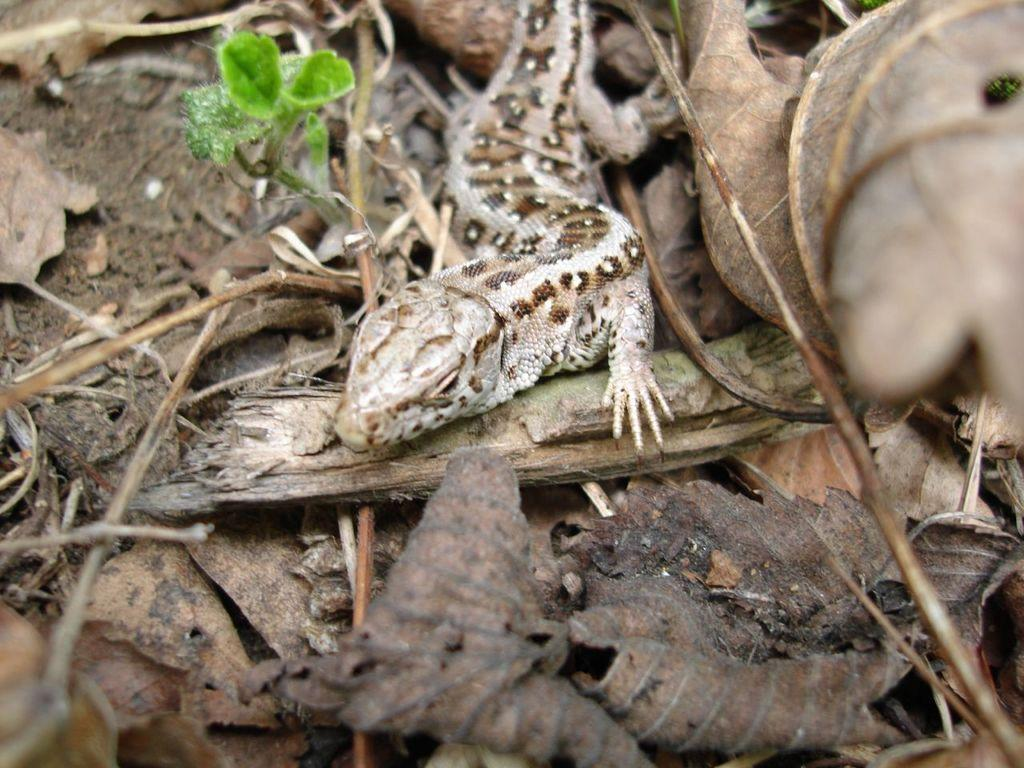What type of animal is in the image? There is a lizard in the image. Where is the lizard located? The lizard is on the ground. What else can be found on the ground in the image? There are dry leaves and sticks on the ground. What type of plant is present in the image? There is a plant with green leaves in the image. What color is the quartz in the lizard's mouth? There is no quartz or mouth present in the image, as it features a lizard on the ground with dry leaves, sticks, and a plant with green leaves. 